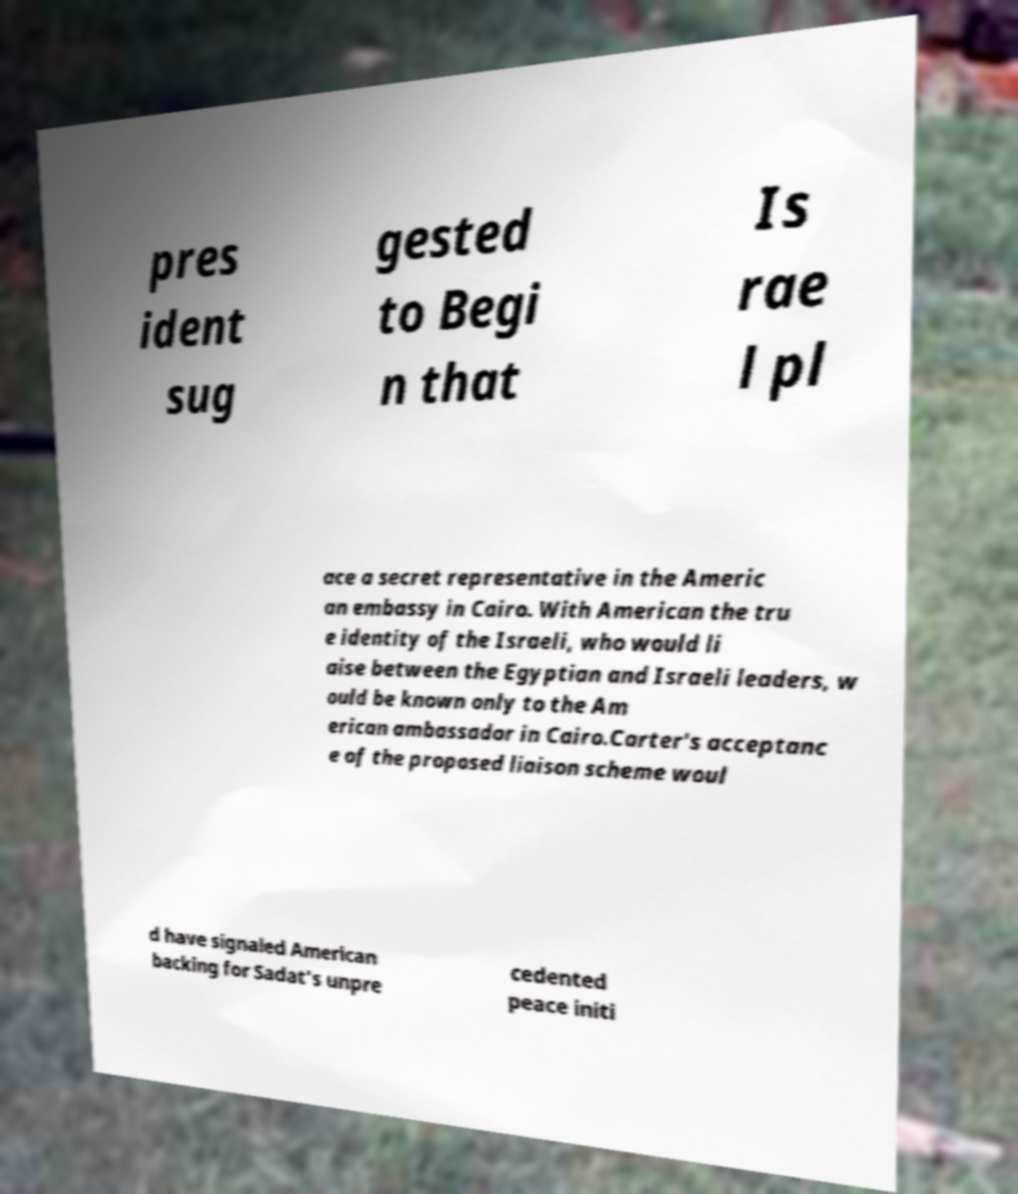Please read and relay the text visible in this image. What does it say? pres ident sug gested to Begi n that Is rae l pl ace a secret representative in the Americ an embassy in Cairo. With American the tru e identity of the Israeli, who would li aise between the Egyptian and Israeli leaders, w ould be known only to the Am erican ambassador in Cairo.Carter's acceptanc e of the proposed liaison scheme woul d have signaled American backing for Sadat's unpre cedented peace initi 